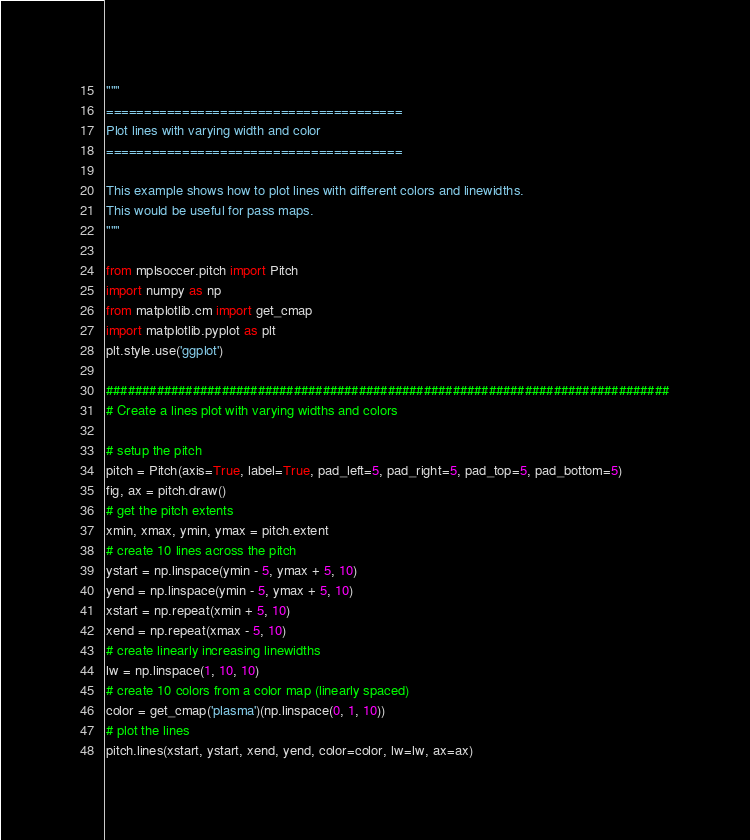<code> <loc_0><loc_0><loc_500><loc_500><_Python_>"""
=======================================
Plot lines with varying width and color
=======================================

This example shows how to plot lines with different colors and linewidths.
This would be useful for pass maps.
"""

from mplsoccer.pitch import Pitch
import numpy as np
from matplotlib.cm import get_cmap
import matplotlib.pyplot as plt
plt.style.use('ggplot')

##############################################################################
# Create a lines plot with varying widths and colors

# setup the pitch
pitch = Pitch(axis=True, label=True, pad_left=5, pad_right=5, pad_top=5, pad_bottom=5)
fig, ax = pitch.draw()
# get the pitch extents
xmin, xmax, ymin, ymax = pitch.extent
# create 10 lines across the pitch
ystart = np.linspace(ymin - 5, ymax + 5, 10)
yend = np.linspace(ymin - 5, ymax + 5, 10)
xstart = np.repeat(xmin + 5, 10)
xend = np.repeat(xmax - 5, 10)
# create linearly increasing linewidths
lw = np.linspace(1, 10, 10)
# create 10 colors from a color map (linearly spaced)
color = get_cmap('plasma')(np.linspace(0, 1, 10))
# plot the lines
pitch.lines(xstart, ystart, xend, yend, color=color, lw=lw, ax=ax)
</code> 